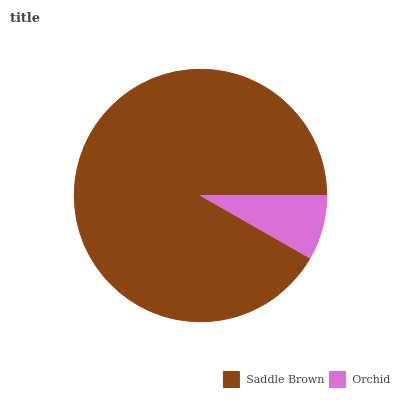Is Orchid the minimum?
Answer yes or no. Yes. Is Saddle Brown the maximum?
Answer yes or no. Yes. Is Orchid the maximum?
Answer yes or no. No. Is Saddle Brown greater than Orchid?
Answer yes or no. Yes. Is Orchid less than Saddle Brown?
Answer yes or no. Yes. Is Orchid greater than Saddle Brown?
Answer yes or no. No. Is Saddle Brown less than Orchid?
Answer yes or no. No. Is Saddle Brown the high median?
Answer yes or no. Yes. Is Orchid the low median?
Answer yes or no. Yes. Is Orchid the high median?
Answer yes or no. No. Is Saddle Brown the low median?
Answer yes or no. No. 